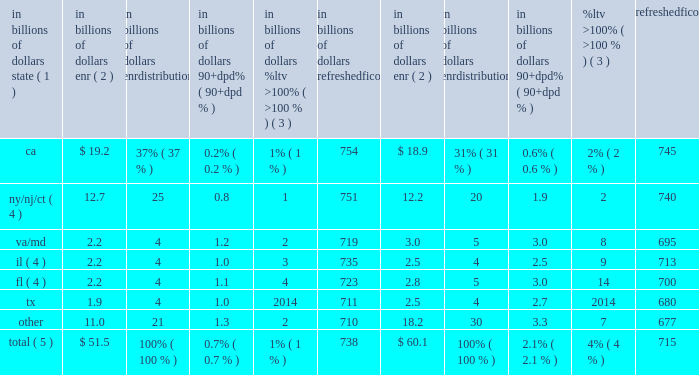During 2015 , continued management actions , primarily the sale or transfer to held-for-sale of approximately $ 1.5 billion of delinquent residential first mortgages , including $ 0.9 billion in the fourth quarter largely associated with the transfer of citifinancial loans to held-for-sale referenced above , were the primary driver of the overall improvement in delinquencies within citi holdings 2019 residential first mortgage portfolio .
Credit performance from quarter to quarter could continue to be impacted by the amount of delinquent loan sales or transfers to held-for-sale , as well as overall trends in hpi and interest rates .
North america residential first mortgages 2014state delinquency trends the tables set forth the six u.s .
States and/or regions with the highest concentration of citi 2019s residential first mortgages. .
Total ( 5 ) $ 51.5 100% ( 100 % ) 0.7% ( 0.7 % ) 1% ( 1 % ) 738 $ 60.1 100% ( 100 % ) 2.1% ( 2.1 % ) 4% ( 4 % ) 715 note : totals may not sum due to rounding .
( 1 ) certain of the states are included as part of a region based on citi 2019s view of similar hpi within the region .
( 2 ) ending net receivables .
Excludes loans in canada and puerto rico , loans guaranteed by u.s .
Government agencies , loans recorded at fair value and loans subject to long term standby commitments ( ltscs ) .
Excludes balances for which fico or ltv data are unavailable .
( 3 ) ltv ratios ( loan balance divided by appraised value ) are calculated at origination and updated by applying market price data .
( 4 ) new york , new jersey , connecticut , florida and illinois are judicial states .
( 5 ) improvement in state trends during 2015 was primarily due to the sale or transfer to held-for-sale of residential first mortgages , including the transfer of citifinancial residential first mortgages to held-for-sale in the fourth quarter of 2015 .
Foreclosures a substantial majority of citi 2019s foreclosure inventory consists of residential first mortgages .
At december 31 , 2015 , citi 2019s foreclosure inventory included approximately $ 0.1 billion , or 0.2% ( 0.2 % ) , of the total residential first mortgage portfolio , compared to $ 0.6 billion , or 0.9% ( 0.9 % ) , at december 31 , 2014 , based on the dollar amount of ending net receivables of loans in foreclosure inventory , excluding loans that are guaranteed by u.s .
Government agencies and loans subject to ltscs .
North america consumer mortgage quarterly credit trends 2014net credit losses and delinquencies 2014home equity citi 2019s home equity loan portfolio consists of both fixed-rate home equity loans and loans extended under home equity lines of credit .
Fixed-rate home equity loans are fully amortizing .
Home equity lines of credit allow for amounts to be drawn for a period of time with the payment of interest only and then , at the end of the draw period , the then-outstanding amount is converted to an amortizing loan ( the interest-only payment feature during the revolving period is standard for this product across the industry ) .
After conversion , the home equity loans typically have a 20-year amortization period .
As of december 31 , 2015 , citi 2019s home equity loan portfolio of $ 22.8 billion consisted of $ 6.3 billion of fixed-rate home equity loans and $ 16.5 billion of loans extended under home equity lines of credit ( revolving helocs ) . .
As of december 31 , 2015 , what was the percentage of the loans extended under home equity lines of credit in the citi 2019s home equity loan portfolio? 
Rationale: as of december 31 , 2015 , 72.4% of the citi 2019s home equity loan portfolio was made of loans extended under home equity lines of credit in the
Computations: (16.5 / 22.8)
Answer: 0.72368. 